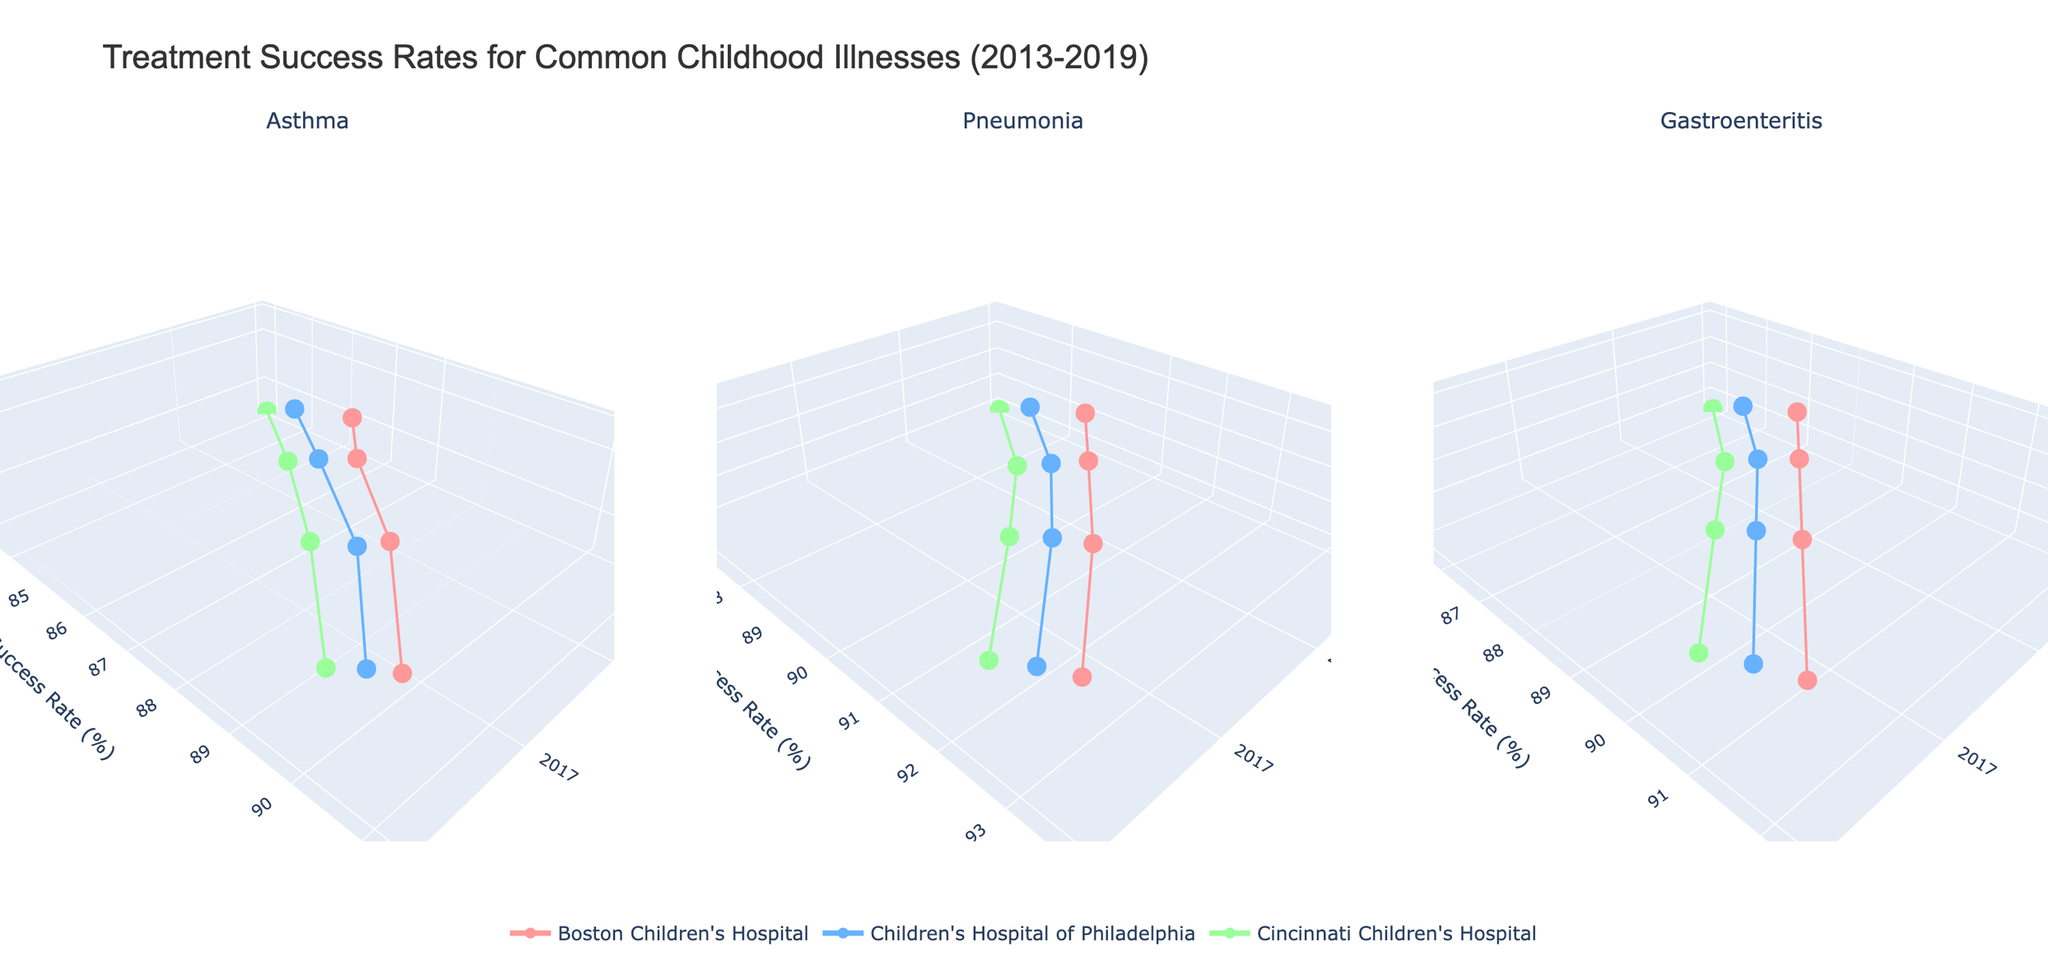What's the title of the figure? The title of the figure is displayed at the top and provides an overview of what the chart represents. It reads, "Treatment Success Rates for Common Childhood Illnesses (2013-2019)"
Answer: Treatment Success Rates for Common Childhood Illnesses (2013-2019) Which hospital had the highest success rate for asthma in 2019? Locate the subplot for asthma and identify the data points for the year 2019. The highest success rate for asthma in 2019 belongs to Boston Children's Hospital at 91.2%
Answer: Boston Children's Hospital How did the approach scores for pneumonia change for Cincinnati Children's Hospital from 2013 to 2019? Look at the pneumonia subplot and find the data points for Cincinnati Children's Hospital for the years 2013 and 2019. The approach score increased from 7.4 in 2013 to 8.8 in 2019
Answer: Increased from 7.4 to 8.8 What was the trend in success rates for gastroenteritis across all hospitals from 2013 to 2019? In the gastroenteritis subplot, observe the success rates for each hospital from 2013 to 2019. Success rates for all hospitals show an increasing trend in this period
Answer: Increasing trend Which illness had the highest average success rate across all hospitals in 2015? Calculate the average success rate for each illness in 2015 by summing the success rates for each hospital and dividing by the number of hospitals. For 2015, pneumonia has the highest average of (90.3 + 89.6 + 88.9) / 3 = 89.6
Answer: Pneumonia Compare the success rates of Boston Children's Hospital and Cincinnati Children's Hospital for asthma in 2017. Which hospital had a higher rate? Examine the subplot for asthma and compare the data points for both hospitals in 2017. Boston Children's Hospital had a success rate of 89.4%, while Cincinnati Children's Hospital had 88.1%
Answer: Boston Children's Hospital In what year did Children's Hospital of Philadelphia achieve an approach score of 8.9 for gastroenteritis? Locate the data points for Children's Hospital of Philadelphia in the gastroenteritis subplot and find the year when the approach score was 8.9. It was achieved in 2019
Answer: 2019 Was there any year where the success rate for pneumonia was the same for both Boston Children's Hospital and Children's Hospital of Philadelphia? Find and compare the success rates for pneumonia for both hospitals across all years. In 2015, the success rates are 90.3 for Boston Children's Hospital and 89.6 for Children's Hospital of Philadelphia, indicating no exact matches
Answer: No If we look at asthma, which hospital showed the greatest improvement in success rate from 2013 to 2019? To find the greatest improvement, calculate the difference in success rates from 2013 to 2019 for each hospital. Boston Children's Hospital's success rate improved by 91.2 - 85.2 = 6.0, which is the greatest improvement among the hospitals
Answer: Boston Children's Hospital What is the relationship between approach score and success rate for pneumonia in 2019? Observe the data points for pneumonia in 2019 across all hospitals. Boston Children's Hospital, with the highest approach score of 9.3, also shows the highest success rate of 93.7%, indicating a positive relationship
Answer: Positive relationship 